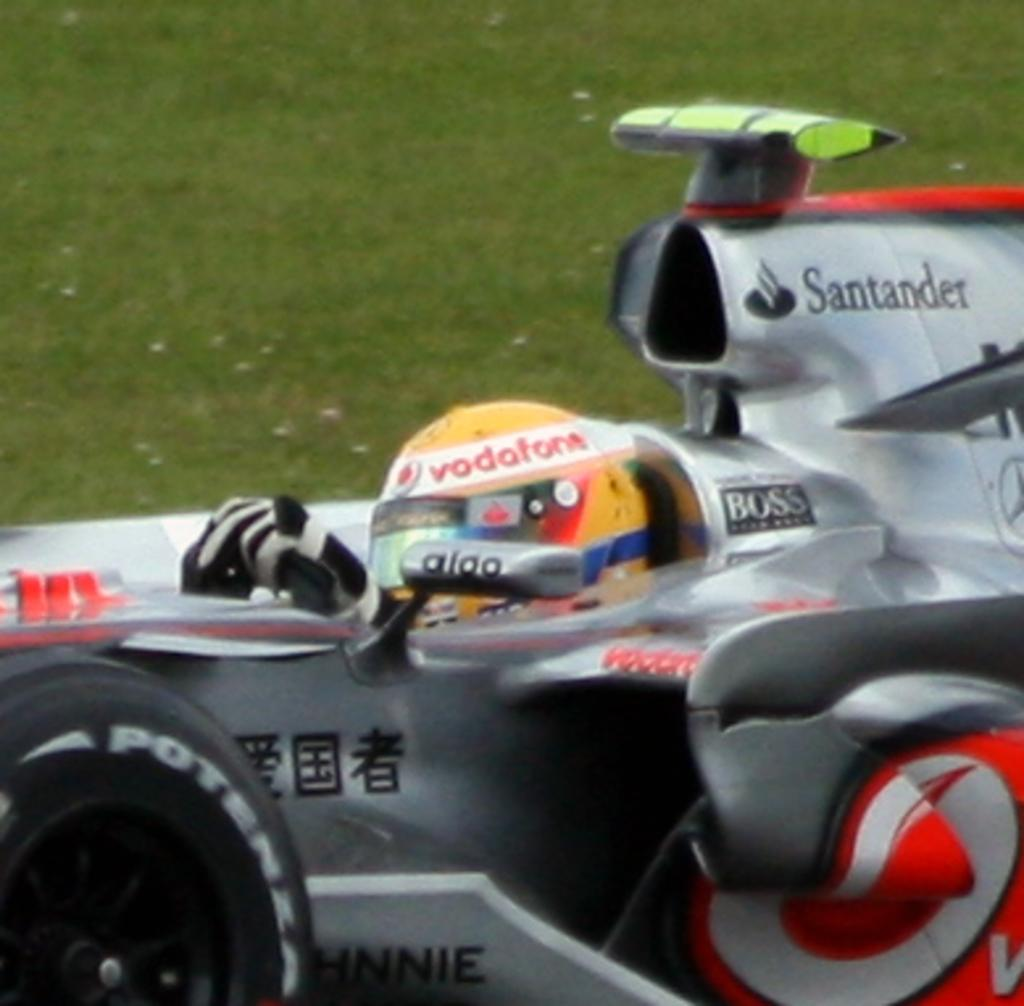<image>
Relay a brief, clear account of the picture shown. A race car driver sponsored by Vodafone and Santander sits in his silver race car. 